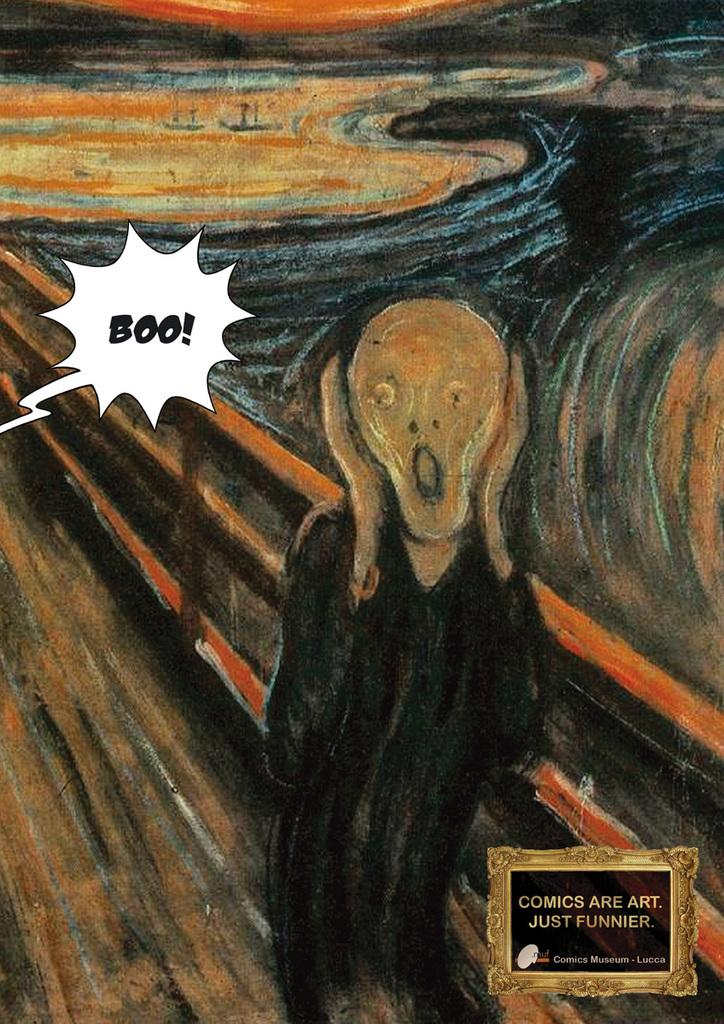What is the main subject of the image? The main subject of the image is a painting. Can you describe any specific features of the painting? Yes, there is a watermark on the right side of the painting. What type of toothpaste is used to create the watermark on the painting? There is no toothpaste present in the image, and the watermark is not created using toothpaste. 